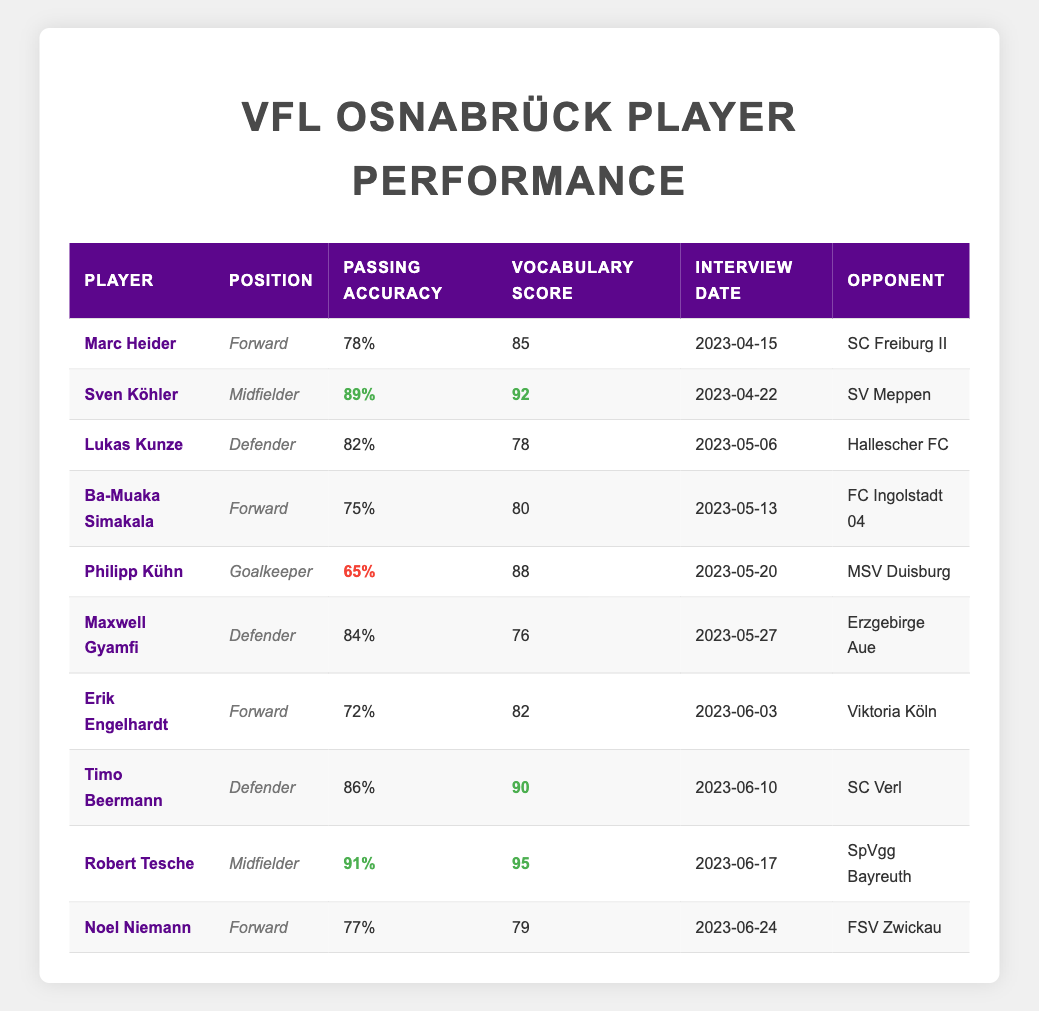What is the passing accuracy of Robert Tesche? The passing accuracy for Robert Tesche is listed in the table under his name, which shows 91%.
Answer: 91% Who has the highest vocabulary score among the players? By reviewing the vocabulary scores for all players, it is evident that Robert Tesche has the highest score at 95.
Answer: 95 Is Timo Beermann a Defender? The position column indicates that Timo Beermann is indeed a Defender.
Answer: Yes What is the average passing accuracy of the Midfielders? The Midfielders are Sven Köhler and Robert Tesche, with passing accuracies of 89% and 91%, respectively. The average is (89 + 91) / 2 = 90%.
Answer: 90% Which Forward has the lowest passing accuracy? Among the Forwards listed, Ba-Muaka Simakala has the lowest passing accuracy of 75%.
Answer: 75% How many players have a vocabulary score above 80? By counting the vocabulary scores, we see that Sven Köhler, Marc Heider, Robert Tesche, Timo Beermann, and Philipp Kühn all exceed 80. This gives us 5 players with scores above 80.
Answer: 5 What is the difference between Timo Beermann’s passing accuracy and Philipp Kühn’s passing accuracy? Timo Beermann has a passing accuracy of 86%, and Philipp Kühn has 65%. The difference is 86 - 65 = 21%.
Answer: 21% Which player has the second highest passing accuracy? The second highest passing accuracy is 89% from Sven Köhler, ranking just below Robert Tesche's 91%.
Answer: 89% Was there a player who had a vocabulary score lower than 80? Yes, Maxwell Gyamfi had a vocabulary score of 76, indicating it is less than 80.
Answer: Yes 